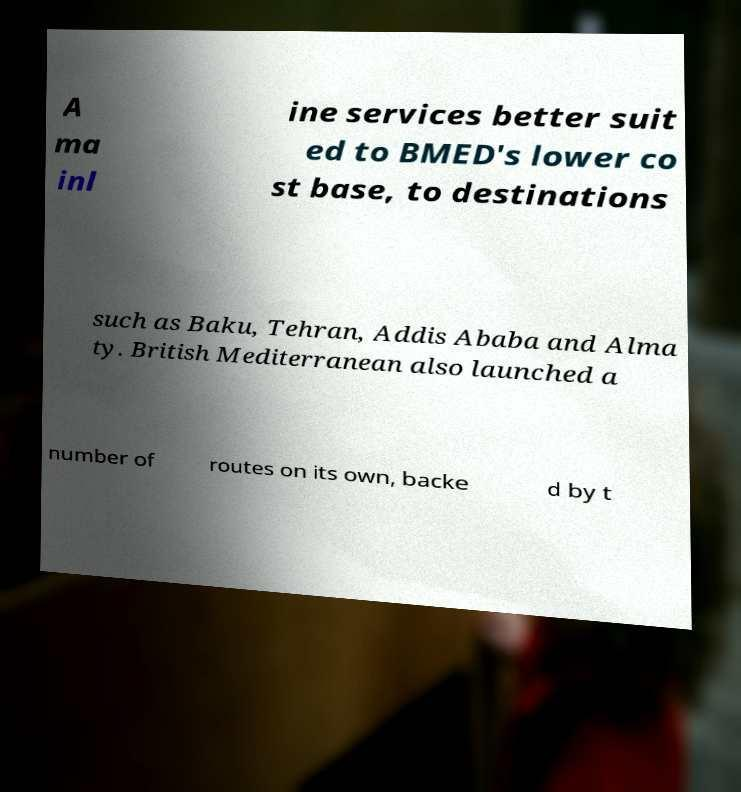There's text embedded in this image that I need extracted. Can you transcribe it verbatim? A ma inl ine services better suit ed to BMED's lower co st base, to destinations such as Baku, Tehran, Addis Ababa and Alma ty. British Mediterranean also launched a number of routes on its own, backe d by t 